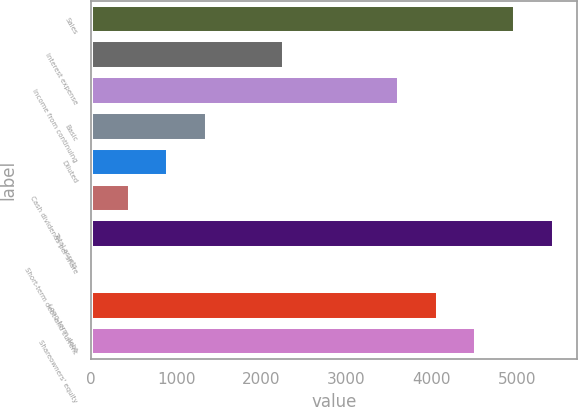<chart> <loc_0><loc_0><loc_500><loc_500><bar_chart><fcel>Sales<fcel>Interest expense<fcel>Income from continuing<fcel>Basic<fcel>Diluted<fcel>Cash dividends per share<fcel>Total assets<fcel>Short-term debt and current<fcel>Long-term debt<fcel>Shareowners' equity<nl><fcel>4977.6<fcel>2262.6<fcel>3620.1<fcel>1357.6<fcel>905.1<fcel>452.6<fcel>5430.1<fcel>0.1<fcel>4072.6<fcel>4525.1<nl></chart> 